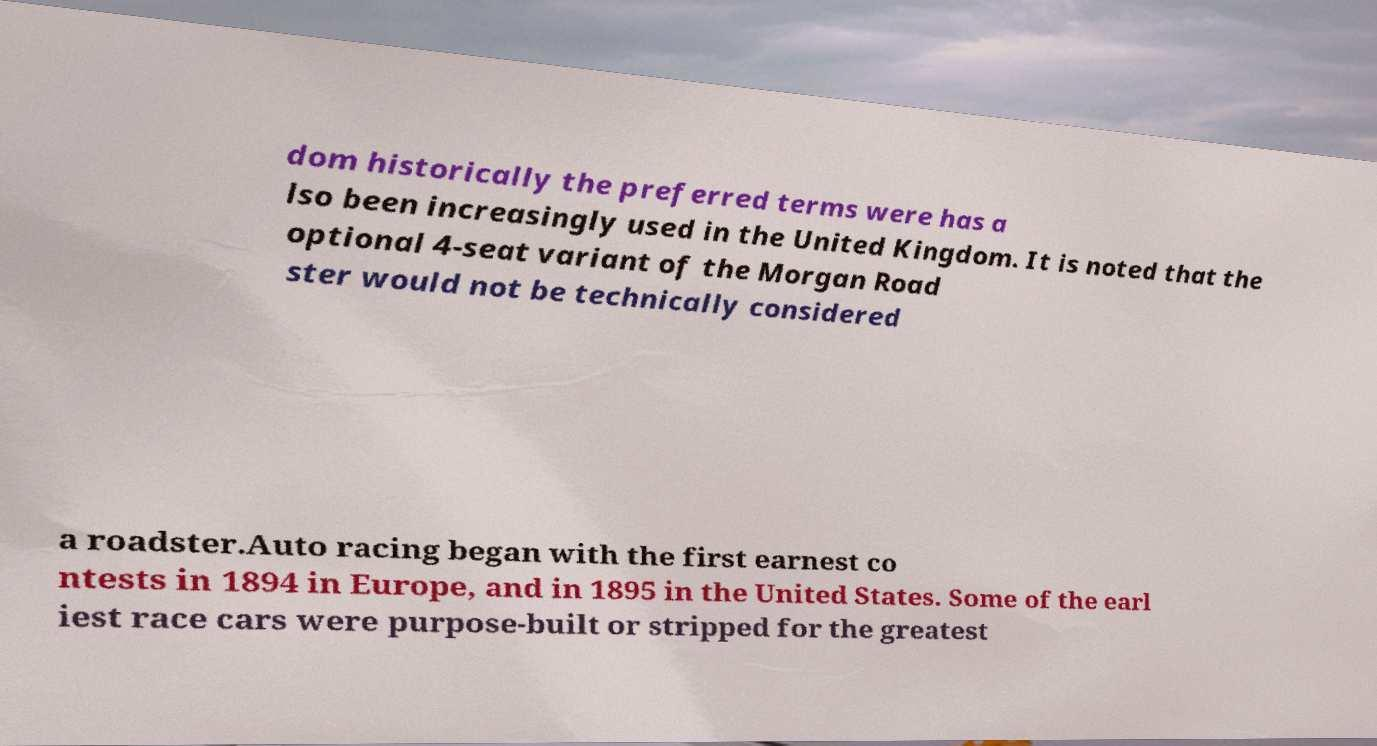Please read and relay the text visible in this image. What does it say? dom historically the preferred terms were has a lso been increasingly used in the United Kingdom. It is noted that the optional 4-seat variant of the Morgan Road ster would not be technically considered a roadster.Auto racing began with the first earnest co ntests in 1894 in Europe, and in 1895 in the United States. Some of the earl iest race cars were purpose-built or stripped for the greatest 